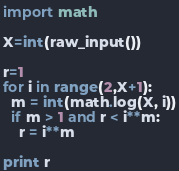<code> <loc_0><loc_0><loc_500><loc_500><_Python_>import math

X=int(raw_input())

r=1
for i in range(2,X+1):
  m = int(math.log(X, i))
  if m > 1 and r < i**m:
    r = i**m

print r
</code> 